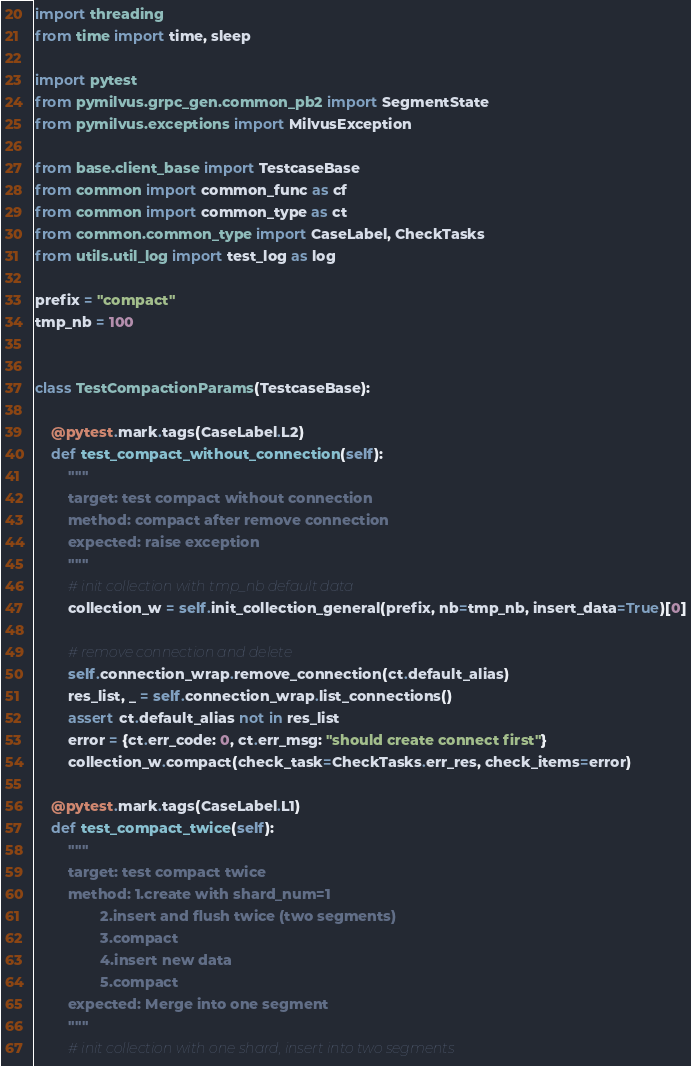Convert code to text. <code><loc_0><loc_0><loc_500><loc_500><_Python_>import threading
from time import time, sleep

import pytest
from pymilvus.grpc_gen.common_pb2 import SegmentState
from pymilvus.exceptions import MilvusException

from base.client_base import TestcaseBase
from common import common_func as cf
from common import common_type as ct
from common.common_type import CaseLabel, CheckTasks
from utils.util_log import test_log as log

prefix = "compact"
tmp_nb = 100


class TestCompactionParams(TestcaseBase):

    @pytest.mark.tags(CaseLabel.L2)
    def test_compact_without_connection(self):
        """
        target: test compact without connection
        method: compact after remove connection
        expected: raise exception
        """
        # init collection with tmp_nb default data
        collection_w = self.init_collection_general(prefix, nb=tmp_nb, insert_data=True)[0]

        # remove connection and delete
        self.connection_wrap.remove_connection(ct.default_alias)
        res_list, _ = self.connection_wrap.list_connections()
        assert ct.default_alias not in res_list
        error = {ct.err_code: 0, ct.err_msg: "should create connect first"}
        collection_w.compact(check_task=CheckTasks.err_res, check_items=error)

    @pytest.mark.tags(CaseLabel.L1)
    def test_compact_twice(self):
        """
        target: test compact twice
        method: 1.create with shard_num=1
                2.insert and flush twice (two segments)
                3.compact
                4.insert new data
                5.compact
        expected: Merge into one segment
        """
        # init collection with one shard, insert into two segments</code> 